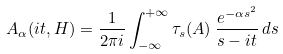Convert formula to latex. <formula><loc_0><loc_0><loc_500><loc_500>A _ { \alpha } ( i t , H ) = \frac { 1 } { 2 \pi i } \int _ { - \infty } ^ { + \infty } \tau _ { s } ( A ) \, \frac { e ^ { - \alpha s ^ { 2 } } } { s - i t } \, d s</formula> 